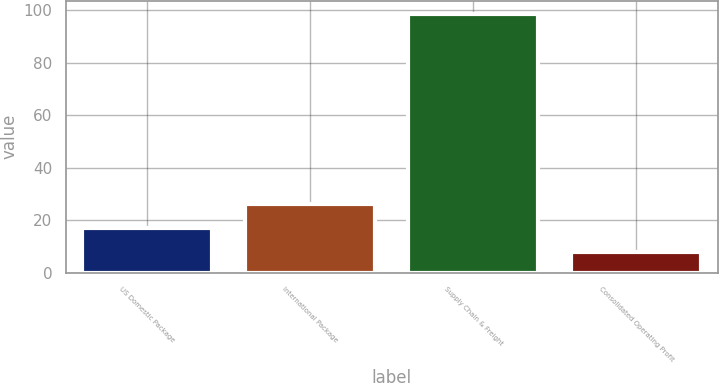Convert chart to OTSL. <chart><loc_0><loc_0><loc_500><loc_500><bar_chart><fcel>US Domestic Package<fcel>International Package<fcel>Supply Chain & Freight<fcel>Consolidated Operating Profit<nl><fcel>17.07<fcel>26.14<fcel>98.7<fcel>8<nl></chart> 